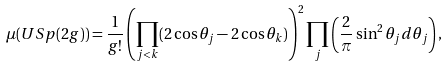<formula> <loc_0><loc_0><loc_500><loc_500>\mu ( U S p ( 2 g ) ) = \frac { 1 } { g ! } \left ( \prod _ { j < k } ( 2 \cos \theta _ { j } - 2 \cos \theta _ { k } ) \right ) ^ { 2 } \prod _ { j } \left ( \frac { 2 } { \pi } \sin ^ { 2 } \theta _ { j } d \theta _ { j } \right ) ,</formula> 